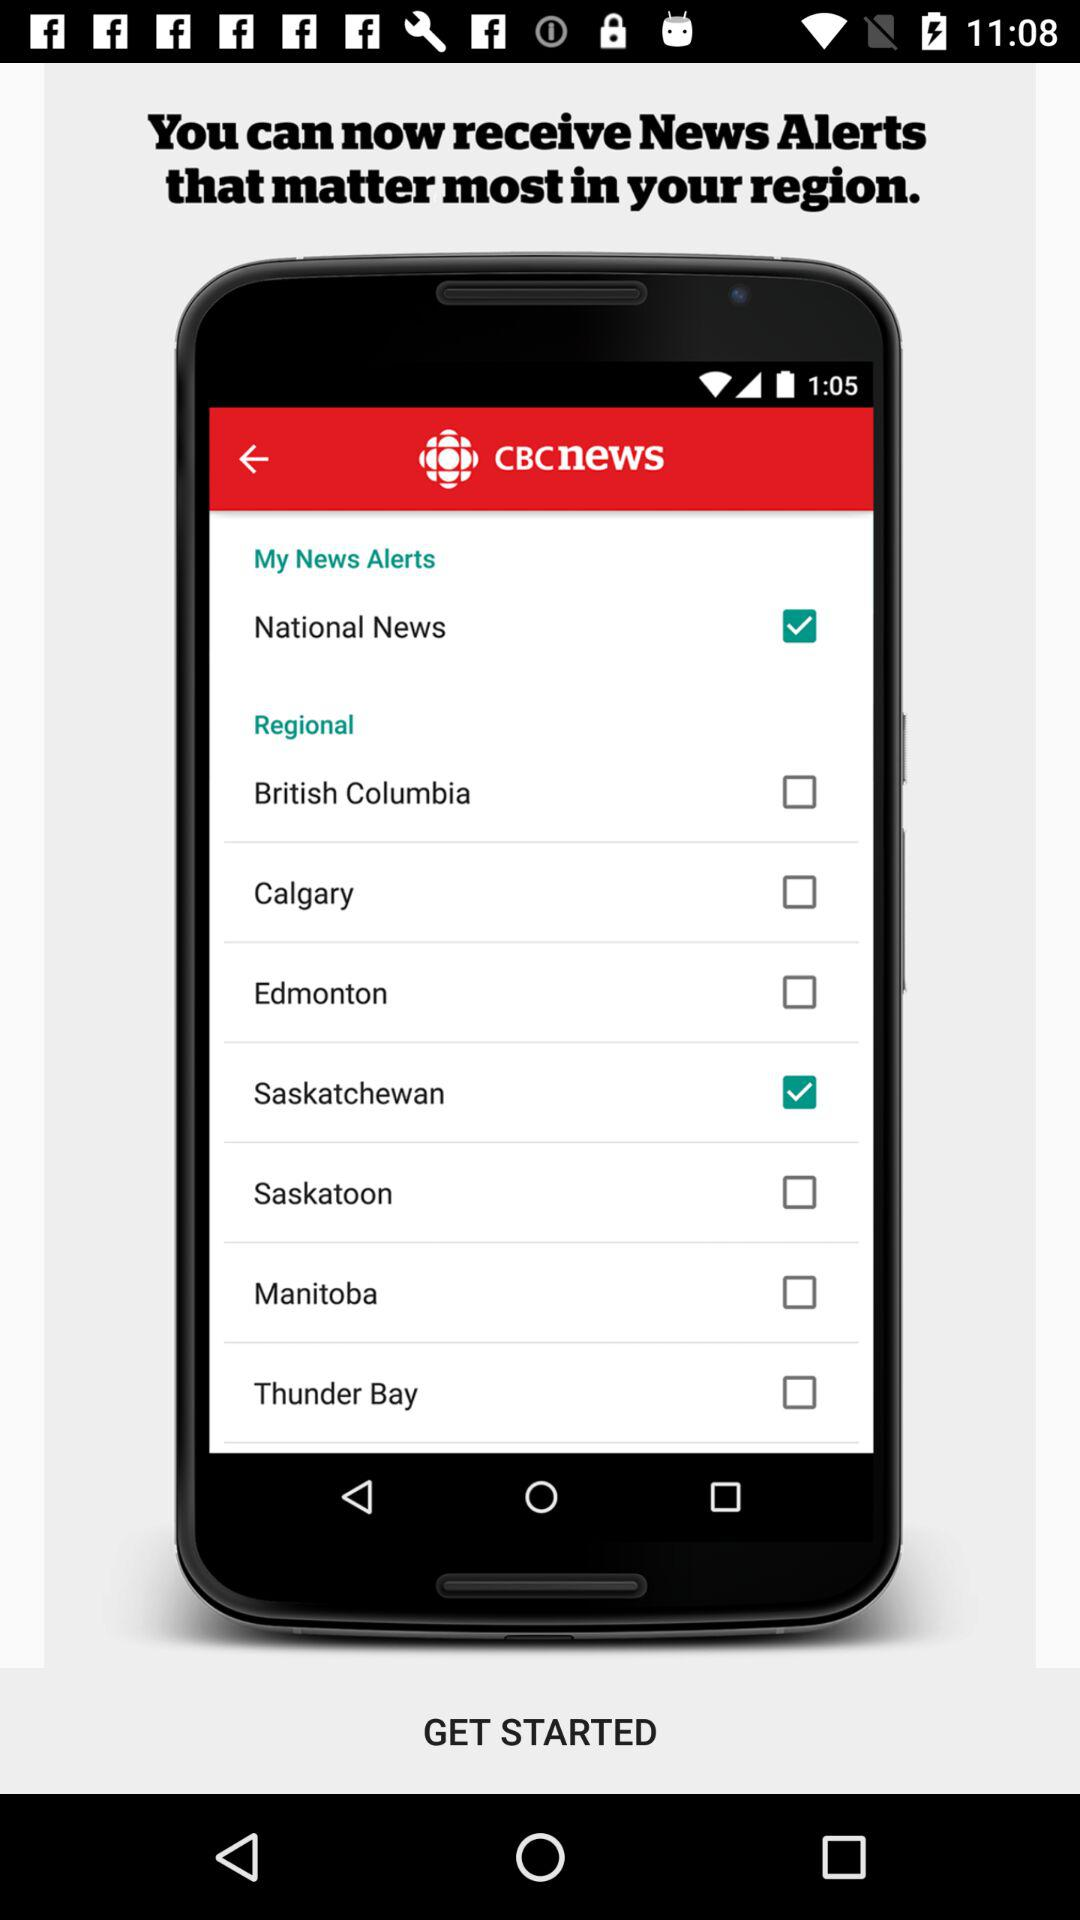What is the status of "National News"? The status of "National News" is "on". 